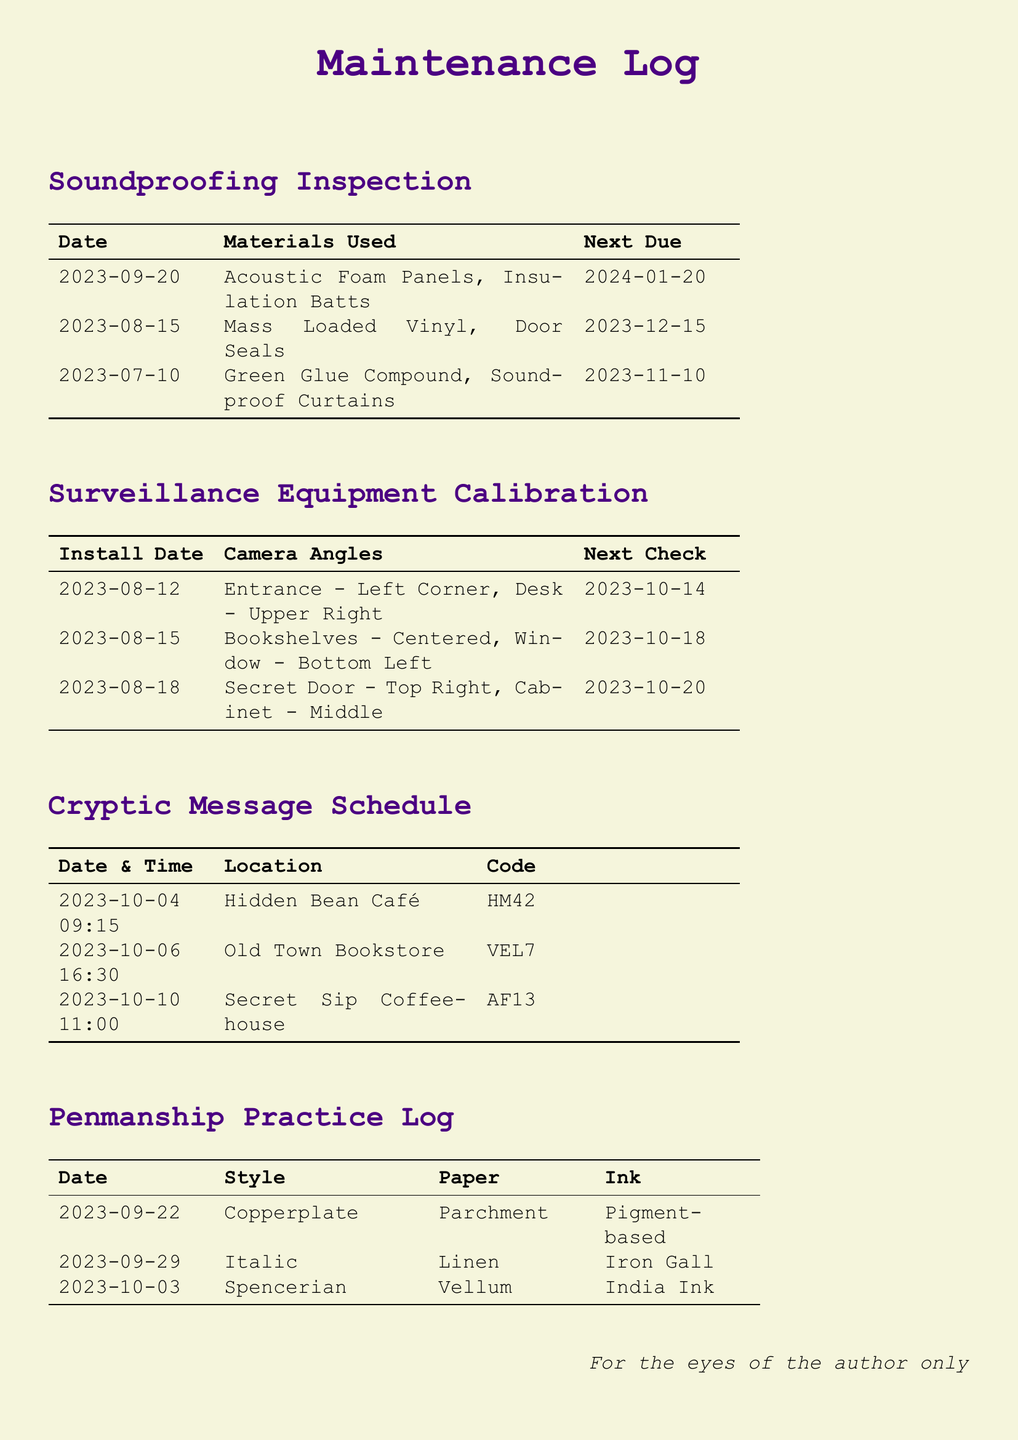What materials were used on 2023-09-20? The materials listed for that date are Acoustic Foam Panels and Insulation Batts.
Answer: Acoustic Foam Panels, Insulation Batts What is the purpose of the code HM42? HM42 is a cryptic message left at Hidden Bean Café on a specific date and time.
Answer: Cryptic message Which handwriting style was practiced on 2023-10-03? On that date, the style practiced was Spencerian.
Answer: Spencerian When is the next calibration check after 2023-08-15? The next check after that date is scheduled for 2023-10-18.
Answer: 2023-10-18 What location is associated with the code VEL7? The code VEL7 is associated with Old Town Bookstore.
Answer: Old Town Bookstore How many different materials were used in the soundproofing inspection? Three unique materials were listed in the inspection log.
Answer: Three What kind of ink was used on 2023-09-29? The ink used on that date was Iron Gall.
Answer: Iron Gall What was the installation date for the surveillance equipment at the entrance? The installation date for the entrance equipment was 2023-08-12.
Answer: 2023-08-12 How many cryptic messages were scheduled in the log? There are three scheduled cryptic messages in the log.
Answer: Three 